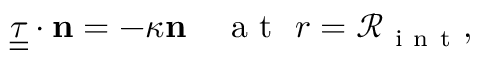<formula> <loc_0><loc_0><loc_500><loc_500>\underline { { \underline { \tau } } } \cdot { n } = - \kappa { n } \quad a t \ r = \mathcal { R } _ { i n t } ,</formula> 